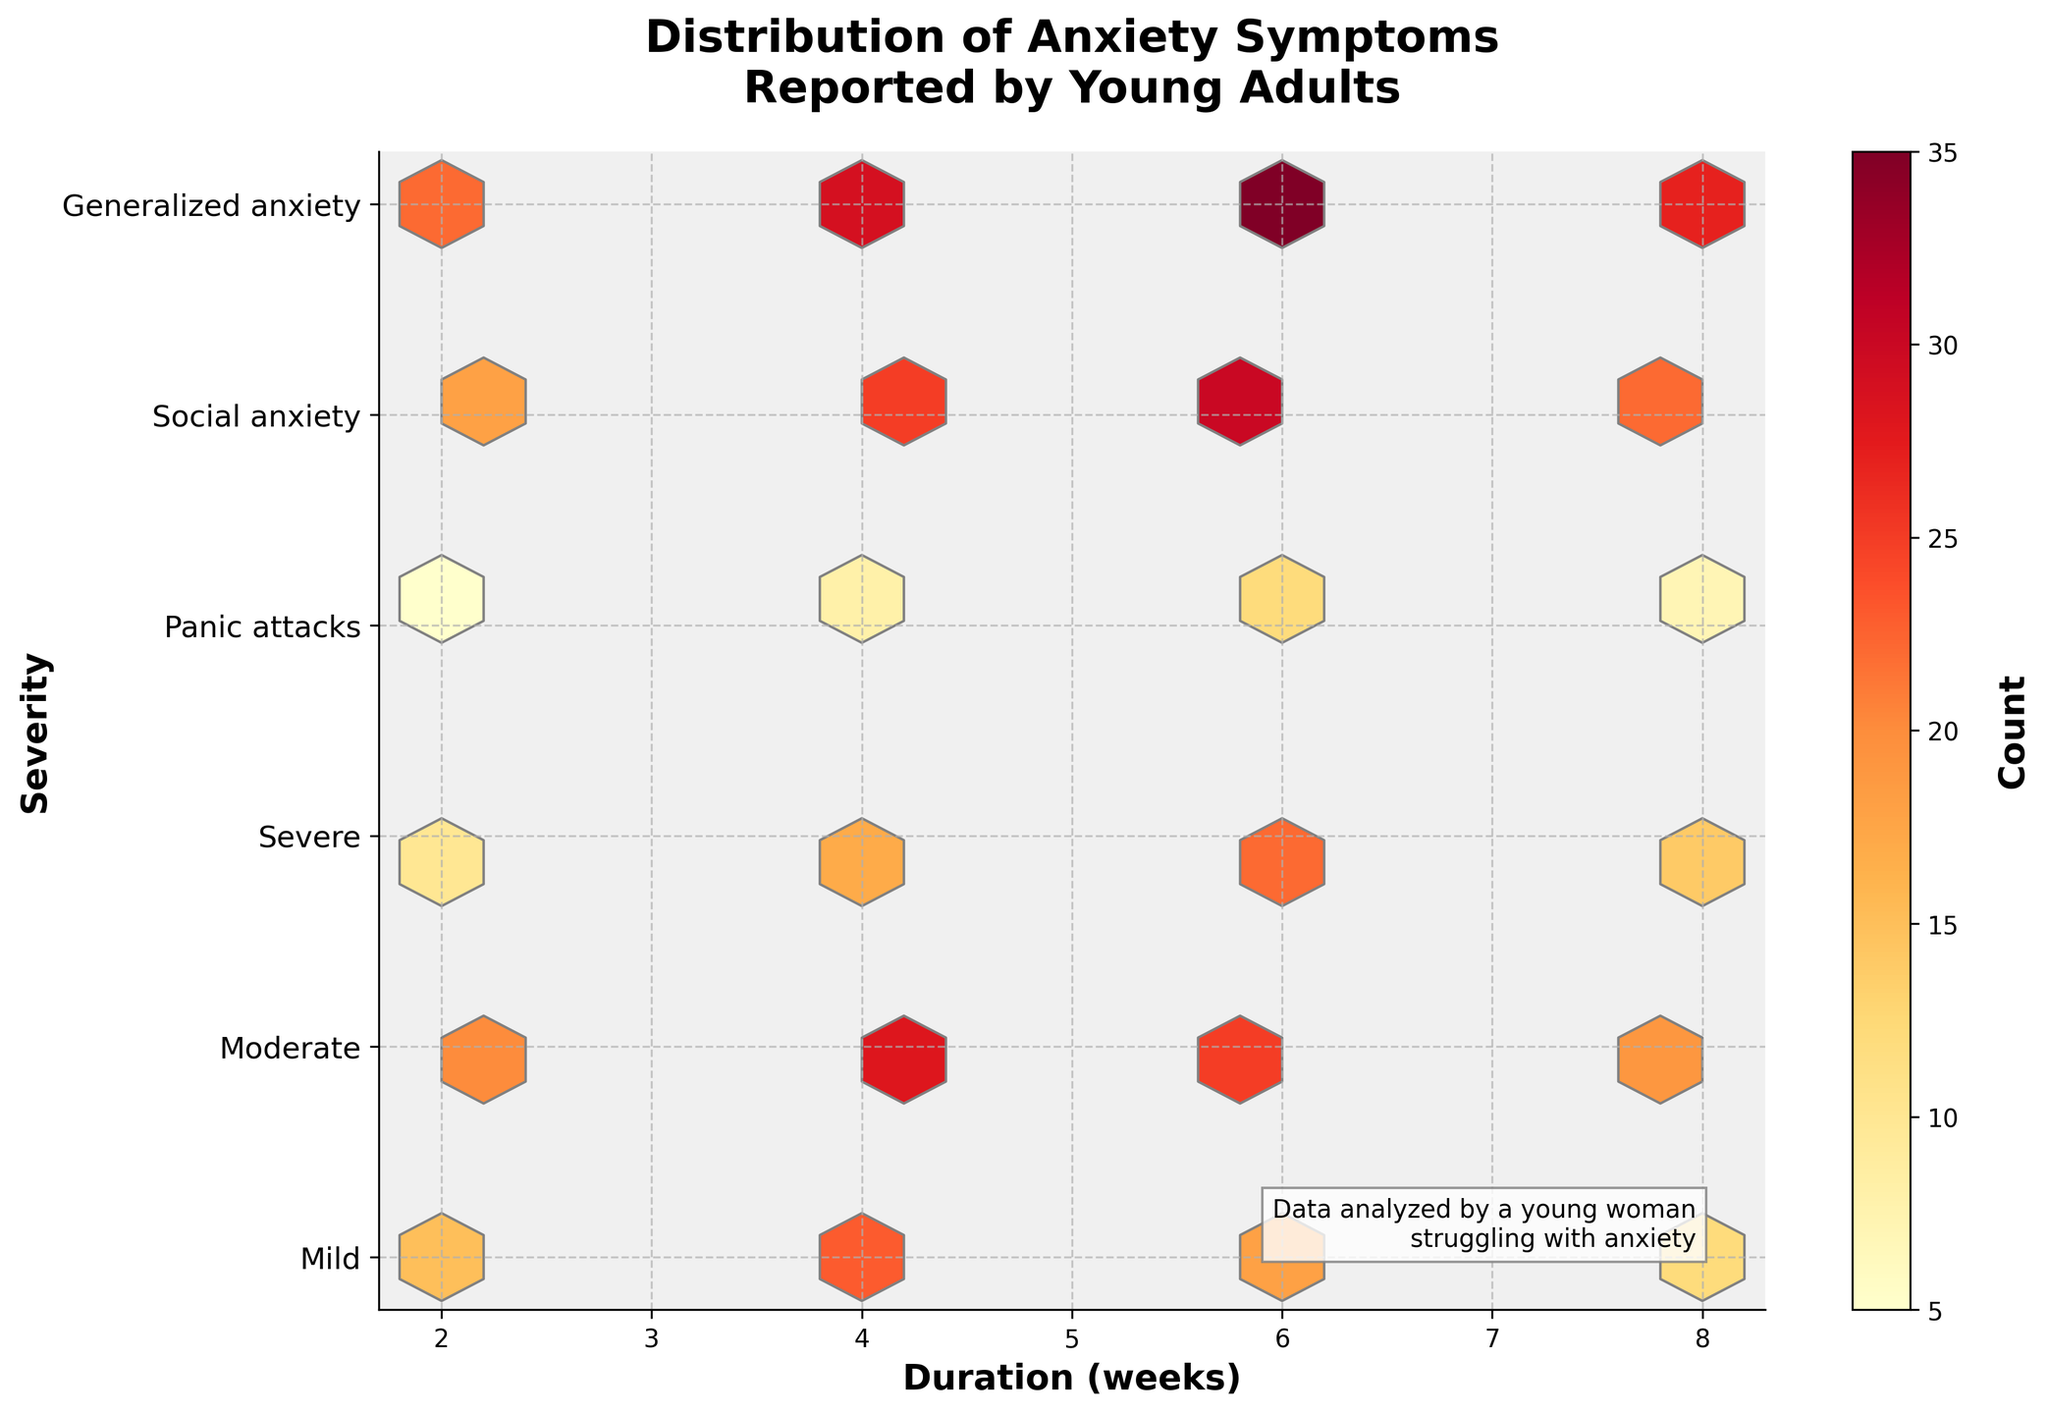What is the title of the plot? The title of the plot is located at the top and is descriptive of the data being shown.
Answer: Distribution of Anxiety Symptoms Reported by Young Adults How many levels of severity are represented in the plot? The y-axis lists the different severity levels, each corresponding to an anxiety condition. Counting these levels provides the answer.
Answer: Six What does a darker hexbin color indicate? The color intensity in a hexbin plot represents the count of data within each bin. Darker colors suggest higher numbers.
Answer: Higher count of reported symptoms Which severity level has the highest count for a duration of 6 weeks? Identify the hexbin that has the darkest color within the column representing 6 weeks duration on the x-axis. Look at the y-axis for its severity level.
Answer: Generalized anxiety What is the trend in severity levels as the duration increases from 2 to 8 weeks? Observe the overall color change on the plot from left (2 weeks) to right (8 weeks) along each severity level to determine if there is an increasing or decreasing trend in reports.
Answer: Increasing Which severity level exhibits the least clustering of reported symptoms? Identify the level with fewer and lighter colored hexagons. This level will have fewer reports spread out, showing less clustering.
Answer: Panic attacks Is the count of reported symptoms generally higher for shorter or longer durations? By comparing the color intensity on the left side (short duration) versus the right side (long duration) of the plot, deduce whether symptoms are more frequently reported sooner or later.
Answer: Longer durations Which severity levels show a consistently high count across all durations? Look for severity levels on the y-axis that exhibit consistently darker hexagons across the x-axis representing various durations.
Answer: Generalized anxiety and Social anxiety What pattern can be observed for Moderate severity over different durations? Examine the hexagons corresponding to the 'Moderate' level across varying duration values for any noticeable trends or color intensity changes.
Answer: Starts high, peaks at 4 weeks, then decreases Which severity shows a peak at 4 weeks duration? Identify the severity level at the y-axis that matches the position of a darker hexbin at the 4 weeks mark on the x-axis.
Answer: Generalized anxiety 